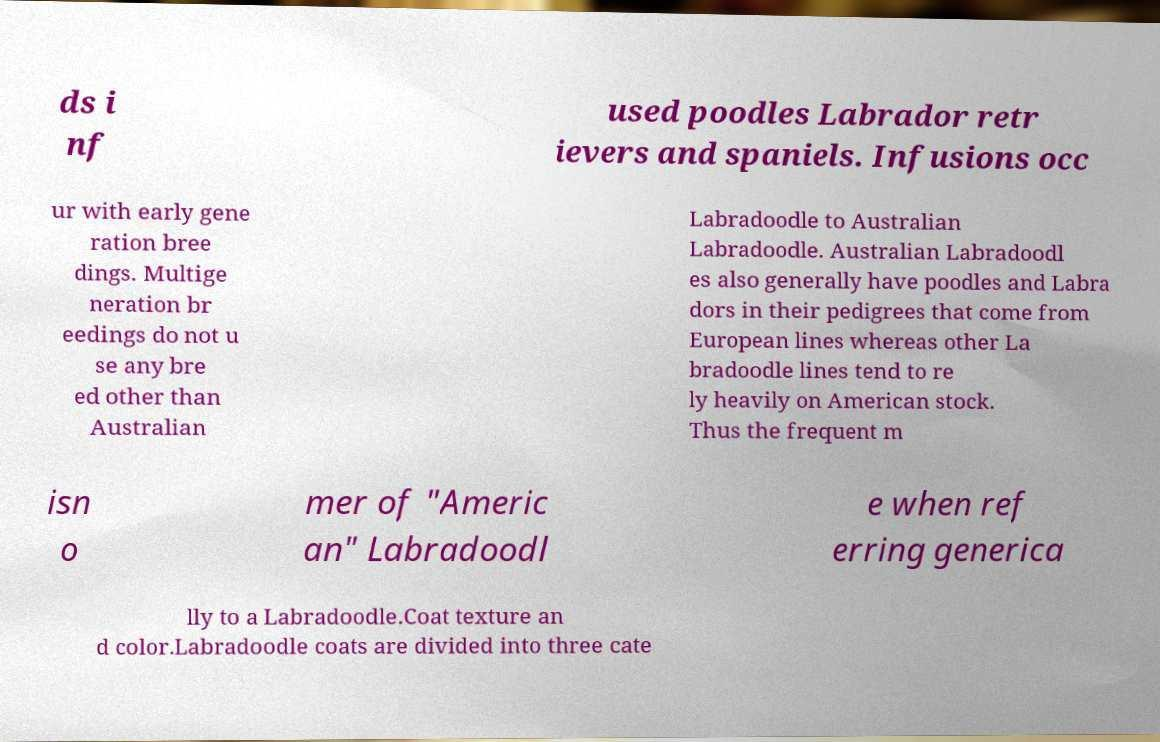Please identify and transcribe the text found in this image. ds i nf used poodles Labrador retr ievers and spaniels. Infusions occ ur with early gene ration bree dings. Multige neration br eedings do not u se any bre ed other than Australian Labradoodle to Australian Labradoodle. Australian Labradoodl es also generally have poodles and Labra dors in their pedigrees that come from European lines whereas other La bradoodle lines tend to re ly heavily on American stock. Thus the frequent m isn o mer of "Americ an" Labradoodl e when ref erring generica lly to a Labradoodle.Coat texture an d color.Labradoodle coats are divided into three cate 